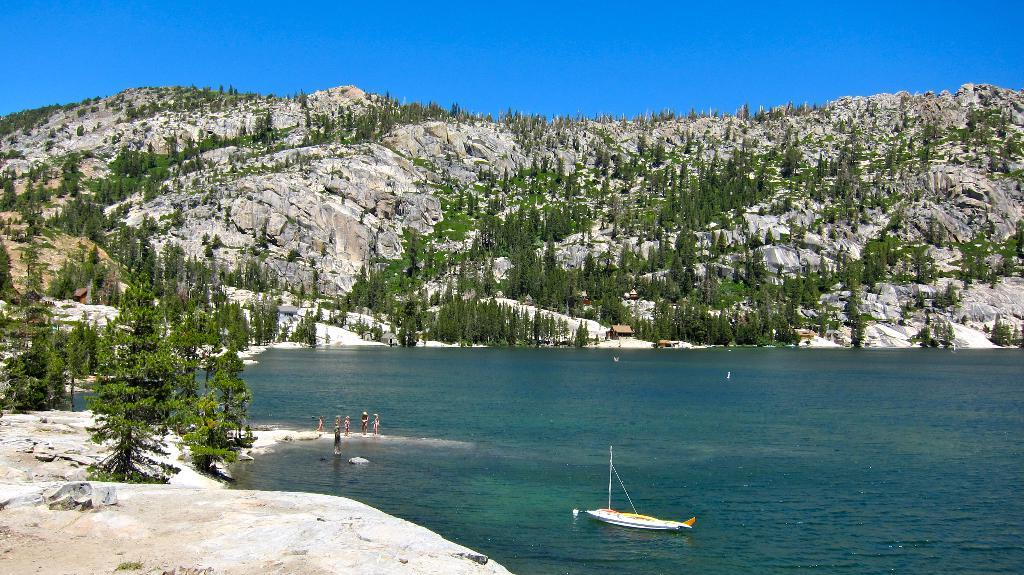What is in the water in the image? There is a boat in the water. What type of natural environment can be seen in the image? Trees and mountains are present in the image. What are the people in the image doing? There are persons standing on the ground. What is visible in the background of the image? The sky is visible in the background. Where is the shelf located in the image? There is no shelf present in the image. Can you describe the person's outfit in the image? There is no person present in the image, so their outfit cannot be described. 